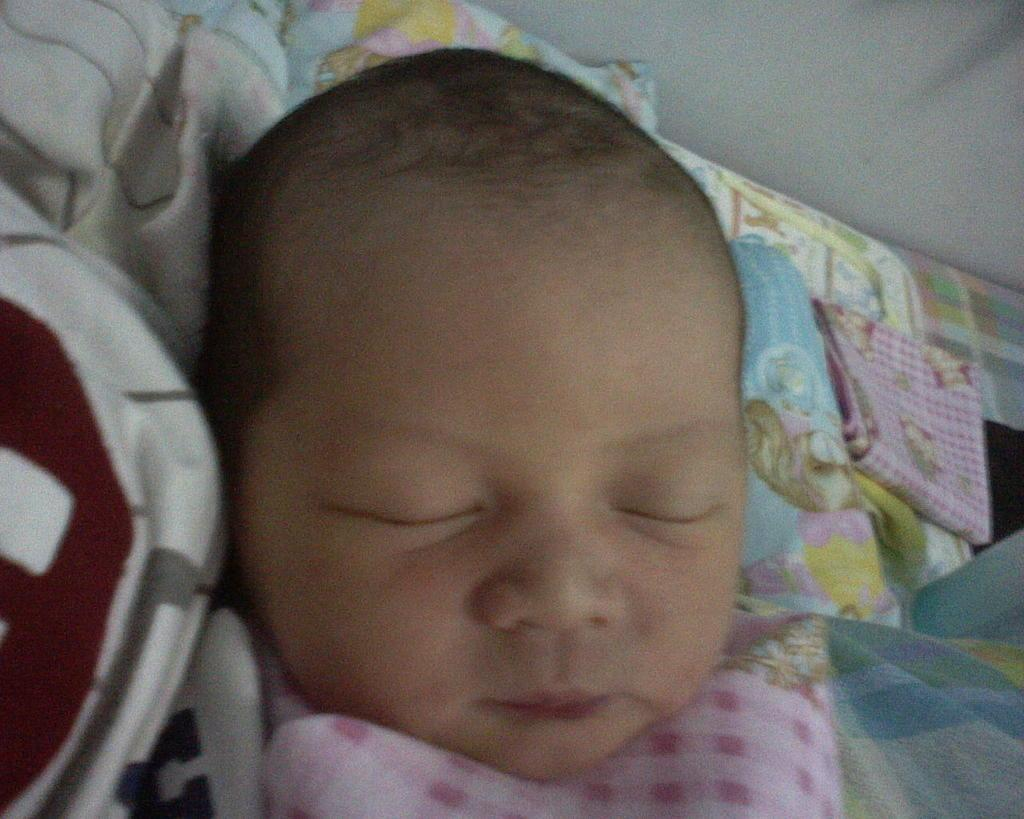What is the main subject of the image? There is a baby in the image. What is the baby laying on? The baby is laying on a sleeping bag. What else can be seen in the image besides the baby? There is a cloth on a bed in the image. What is visible in the top right-hand corner of the image? There is a wall visible in the top right-hand corner of the image. What type of dock can be seen in the image? There is no dock present in the image. Is the baby under attack in the image? There is no indication of an attack in the image; the baby is simply laying on a sleeping bag. 